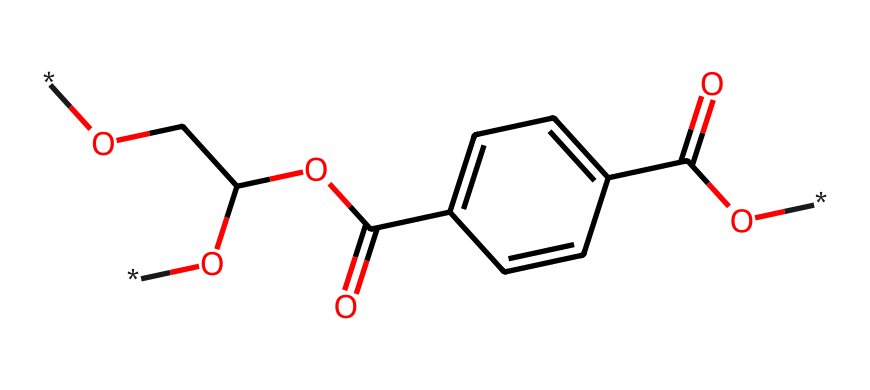What is the primary functional group observed in this structure? The structure contains a carboxylic acid functional group, indicated by the -COOH groups present in the molecule. These groups are characterized by a carbon atom double-bonded to an oxygen atom and single-bonded to a hydroxyl group (-OH).
Answer: carboxylic acid How many carbon atoms are in this chemical structure? By examining the SMILES representation, we can identify the number of carbon atoms present. Counting the "C" symbols indicates there are five carbon atoms in total.
Answer: five Does this chemical contain any aromatic rings? The presence of "c" denotes aromatic carbon atoms in the structure. There is indeed a benzene ring observable by the connectivity of the carbon atoms in a cyclic arrangement, thus confirming the aromatic characteristic.
Answer: yes What is the total number of oxygen atoms in the structure? In the SMILES representation, counting the number of "O" symbols corresponds to the total number of oxygen atoms in the structure. There are three oxygen atoms present.
Answer: three What type of plastic does this structure represent? This chemical structure is indicative of polyethylene terephthalate (PET), which is a type of polyester plastic primarily utilized in packaging, especially in medical equipment due to its stability and clarity.
Answer: polyester What is the molecular weight of this compound? Determining the molecular weight involves calculating the sum of the atomic weights of all the atoms based on their presence in the molecule. For PET, the molecular weight is approximately 192.13 g/mol when calculated using the carbon, hydrogen, and oxygen atomic weights.
Answer: 192.13 g/mol 